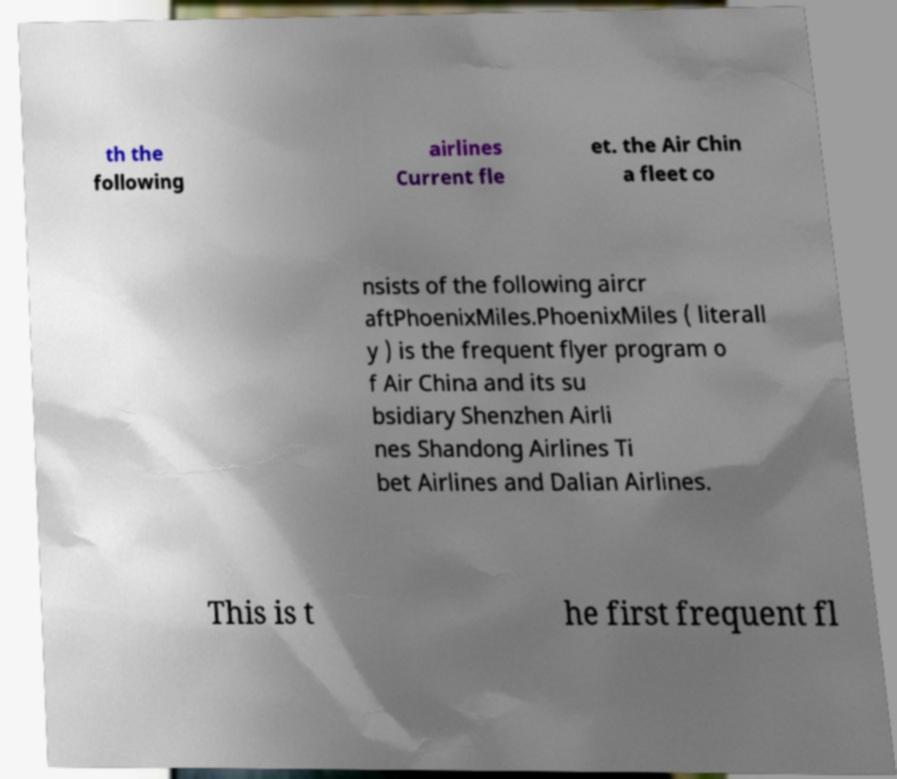Can you accurately transcribe the text from the provided image for me? th the following airlines Current fle et. the Air Chin a fleet co nsists of the following aircr aftPhoenixMiles.PhoenixMiles ( literall y ) is the frequent flyer program o f Air China and its su bsidiary Shenzhen Airli nes Shandong Airlines Ti bet Airlines and Dalian Airlines. This is t he first frequent fl 